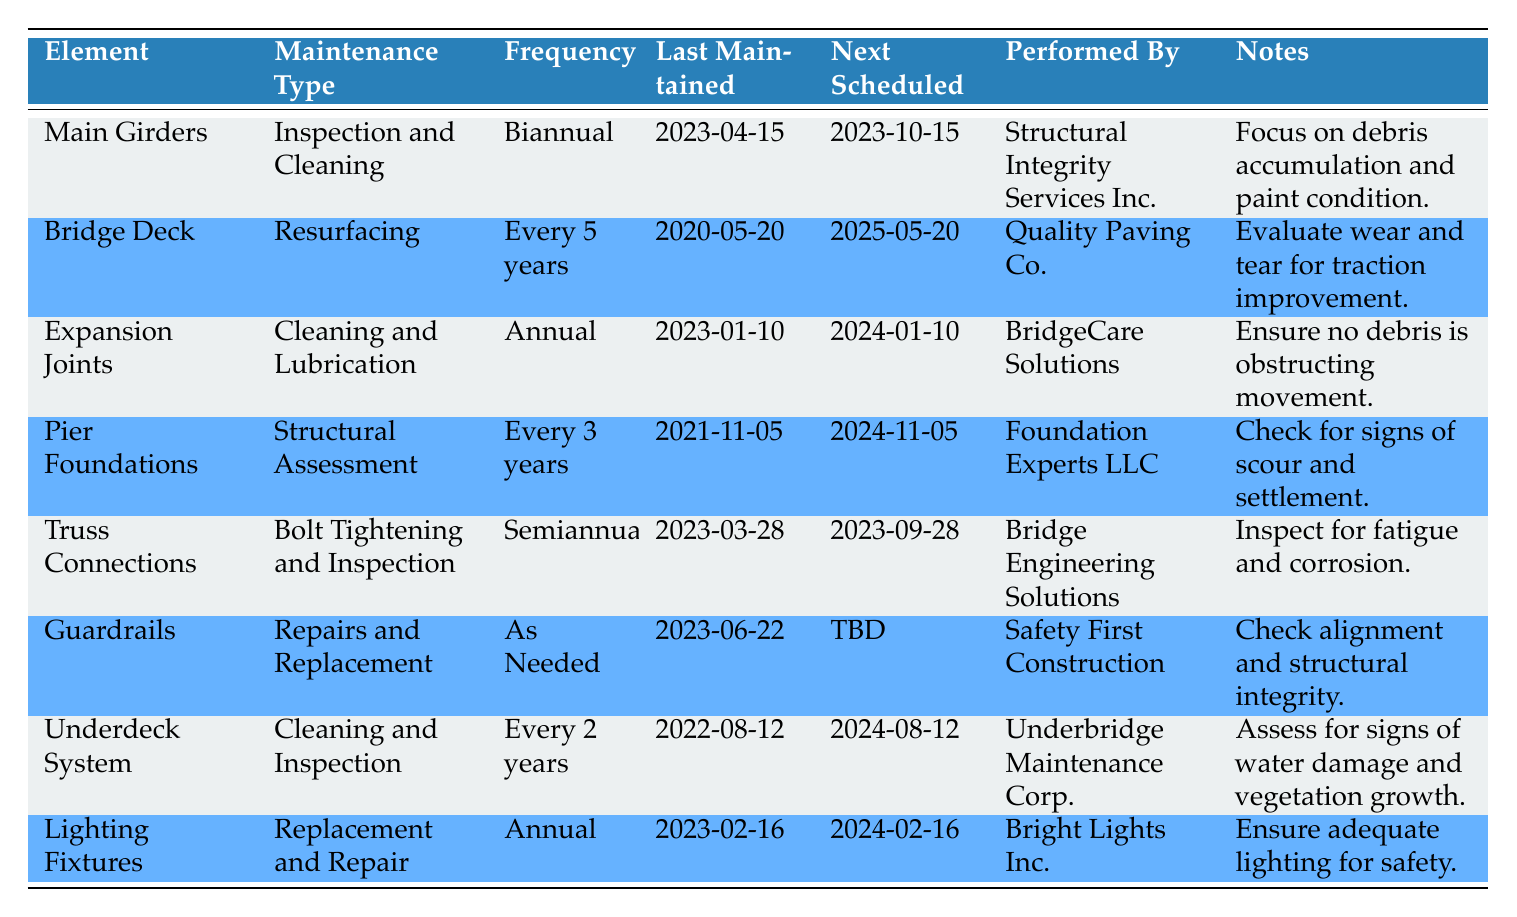What is the maintenance type for the Main Girders? The table lists "Main Girders" under the "Element" column, and the corresponding "Maintenance Type" for it is "Inspection and Cleaning."
Answer: Inspection and Cleaning When is the next scheduled maintenance for the Bridge Deck? To find the next scheduled maintenance for the "Bridge Deck," we look at the "Next Scheduled" column associated with it. The date listed is "2025-05-20."
Answer: 2025-05-20 Which element has a maintenance frequency of every 2 years? The table shows the maintenance frequency for each element. "Underdeck System" is listed with a frequency of "Every 2 years."
Answer: Underdeck System Is the maintenance for the Guardrails scheduled for a specific date? The "Next Scheduled" column for "Guardrails" states "TBD," indicating that there is no specific date currently scheduled for the next maintenance.
Answer: No How many elements require annual maintenance? The table shows that "Expansion Joints," "Lighting Fixtures," and "Guardrails" have a defined frequency of annual maintenance. We count these three entries.
Answer: 2 What is the maintenance type for the Pier Foundations and when was it last maintained? "Pier Foundations" is noted in the table with the maintenance type "Structural Assessment." The "Last Maintained" date is "2021-11-05."
Answer: Structural Assessment, 2021-11-05 Which maintenance company is responsible for cleaning and lubricating the Expansion Joints? By checking the "Performed By" column associated with "Expansion Joints," we find that "BridgeCare Solutions" is responsible for this maintenance type.
Answer: BridgeCare Solutions How many weeks are there between the last maintenance of Truss Connections and the next scheduled maintenance? The last maintenance date for "Truss Connections" is "2023-03-28" and the next scheduled date is "2023-09-28." Calculating the difference: From March 28 to September 28 is 6 months. Since March has 3 days left after the 28th, we have 3 days + 30 days in April + 31 in May + 30 in June + 31 in July + 31 in August + 28 in September = 3 + 30 + 31 + 30 + 31 + 31 + 28 = 6 months or approximately 26 weeks.
Answer: 26 weeks Which bridge element requires resurfacing and when is it next due? The "Bridge Deck" is identified in the table as requiring "Resurfacing." The next scheduled date is "2025-05-20."
Answer: Bridge Deck, 2025-05-20 